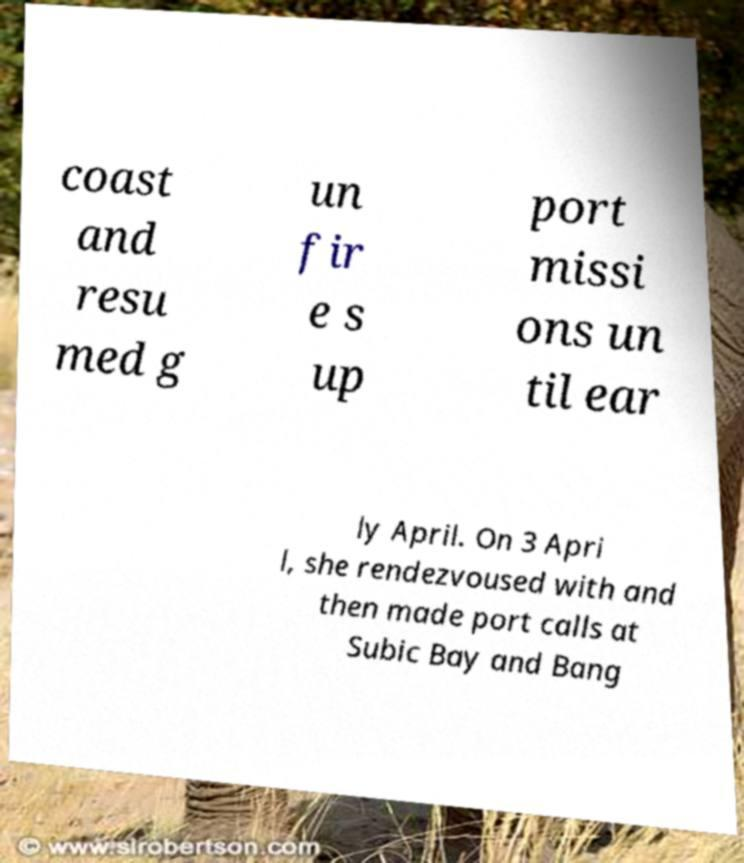Can you read and provide the text displayed in the image?This photo seems to have some interesting text. Can you extract and type it out for me? coast and resu med g un fir e s up port missi ons un til ear ly April. On 3 Apri l, she rendezvoused with and then made port calls at Subic Bay and Bang 